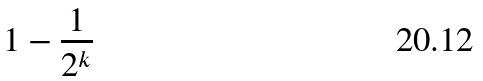<formula> <loc_0><loc_0><loc_500><loc_500>1 - \frac { 1 } { 2 ^ { k } }</formula> 